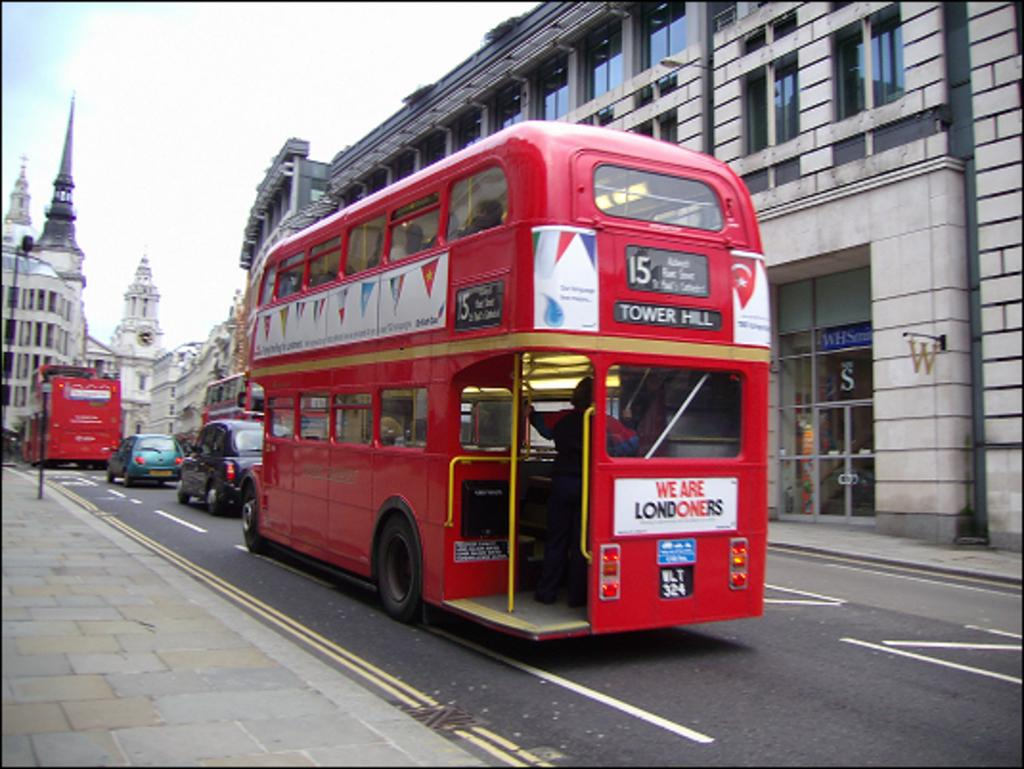<image>
Describe the image concisely. The 15 red doubledecker bus going to Tower Hill driving through a street in London. 